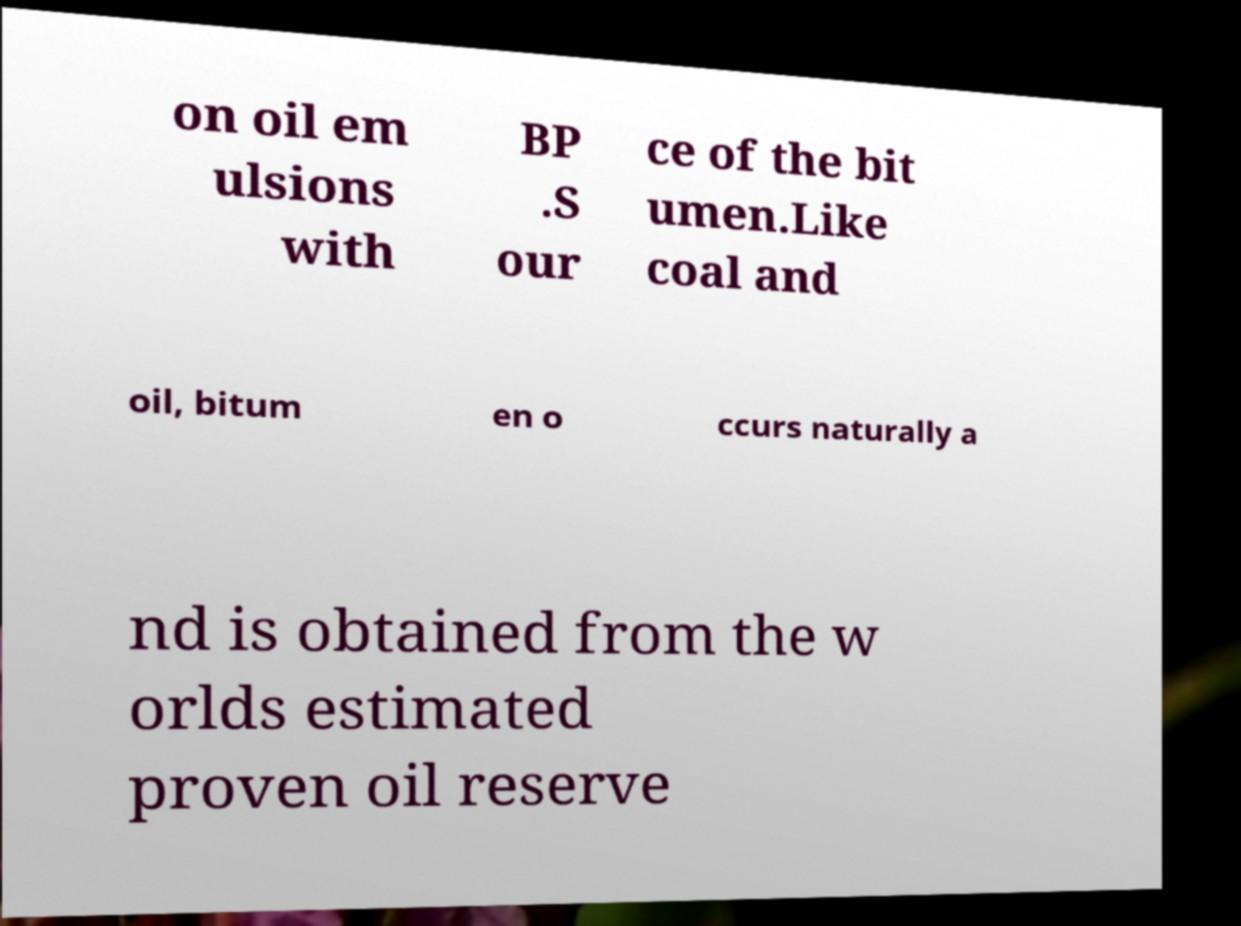There's text embedded in this image that I need extracted. Can you transcribe it verbatim? on oil em ulsions with BP .S our ce of the bit umen.Like coal and oil, bitum en o ccurs naturally a nd is obtained from the w orlds estimated proven oil reserve 